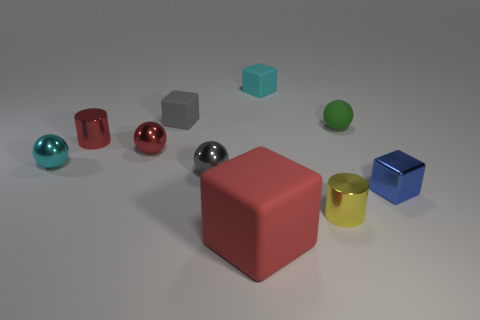Are there any other things that have the same size as the red block?
Your response must be concise. No. Are there any rubber objects that have the same shape as the yellow metal thing?
Keep it short and to the point. No. What material is the small yellow cylinder?
Provide a succinct answer. Metal. There is a cube that is behind the gray metal ball and in front of the small cyan rubber block; what is its size?
Keep it short and to the point. Small. What number of small blue cubes are there?
Ensure brevity in your answer.  1. Are there fewer tiny blue things than large blue shiny cubes?
Make the answer very short. No. What is the material of the yellow cylinder that is the same size as the gray sphere?
Keep it short and to the point. Metal. How many things are shiny objects or large cyan matte balls?
Give a very brief answer. 6. How many things are on the right side of the large rubber thing and in front of the blue cube?
Provide a short and direct response. 1. Is the number of small cubes on the right side of the yellow metallic cylinder less than the number of rubber objects?
Offer a terse response. Yes. 